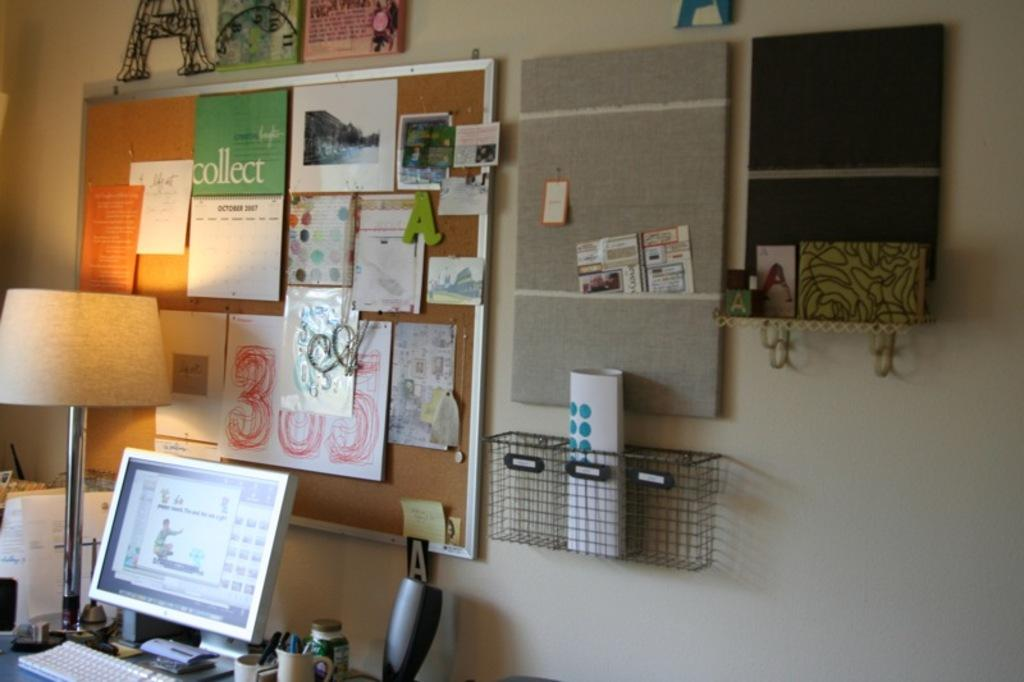What electronic device is present in the image? There is a monitor in the image. What is used for typing on the monitor? There is a keyboard in the image. What items are present for holding liquids? There are mugs and a bottle in the image. What source of light is visible in the image? There is a lamp in the image. What are the flat, rectangular objects in the image? There are boards in the image. What decorative items can be seen on the walls? There are posters in the image. What items are used for displaying photos or artwork? There are frames in the image. What type of container is made of mesh? There is a mesh container in the image. What items are used for writing or drawing? There are papers in the image. What general category of objects can be found in the image? There are various objects in the image. What can be seen in the background of the image? There is a wall in the background of the image. How does the grip on the hammer help in the image? There is no hammer present in the image. What type of stocking is hanging on the wall in the image? There are no stockings present in the image. 